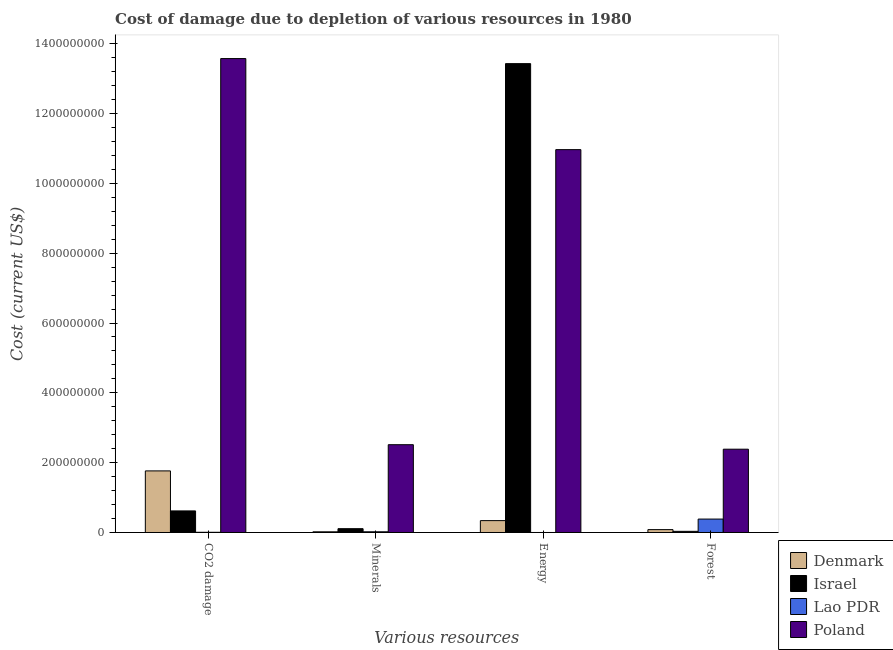How many different coloured bars are there?
Make the answer very short. 4. Are the number of bars on each tick of the X-axis equal?
Your response must be concise. Yes. How many bars are there on the 3rd tick from the left?
Your answer should be compact. 4. How many bars are there on the 2nd tick from the right?
Your answer should be very brief. 4. What is the label of the 3rd group of bars from the left?
Provide a short and direct response. Energy. What is the cost of damage due to depletion of minerals in Israel?
Offer a very short reply. 1.09e+07. Across all countries, what is the maximum cost of damage due to depletion of energy?
Make the answer very short. 1.34e+09. Across all countries, what is the minimum cost of damage due to depletion of minerals?
Your answer should be very brief. 1.95e+06. In which country was the cost of damage due to depletion of coal maximum?
Offer a very short reply. Poland. What is the total cost of damage due to depletion of forests in the graph?
Provide a short and direct response. 2.89e+08. What is the difference between the cost of damage due to depletion of coal in Israel and that in Lao PDR?
Keep it short and to the point. 6.12e+07. What is the difference between the cost of damage due to depletion of energy in Lao PDR and the cost of damage due to depletion of minerals in Poland?
Offer a terse response. -2.51e+08. What is the average cost of damage due to depletion of coal per country?
Ensure brevity in your answer.  3.99e+08. What is the difference between the cost of damage due to depletion of minerals and cost of damage due to depletion of forests in Lao PDR?
Offer a very short reply. -3.64e+07. What is the ratio of the cost of damage due to depletion of coal in Israel to that in Lao PDR?
Make the answer very short. 113.08. Is the cost of damage due to depletion of minerals in Israel less than that in Denmark?
Provide a short and direct response. No. What is the difference between the highest and the second highest cost of damage due to depletion of energy?
Keep it short and to the point. 2.46e+08. What is the difference between the highest and the lowest cost of damage due to depletion of energy?
Offer a very short reply. 1.34e+09. In how many countries, is the cost of damage due to depletion of forests greater than the average cost of damage due to depletion of forests taken over all countries?
Make the answer very short. 1. What does the 1st bar from the left in Forest represents?
Keep it short and to the point. Denmark. How many bars are there?
Give a very brief answer. 16. How many countries are there in the graph?
Provide a short and direct response. 4. How many legend labels are there?
Offer a very short reply. 4. What is the title of the graph?
Give a very brief answer. Cost of damage due to depletion of various resources in 1980 . What is the label or title of the X-axis?
Offer a very short reply. Various resources. What is the label or title of the Y-axis?
Ensure brevity in your answer.  Cost (current US$). What is the Cost (current US$) of Denmark in CO2 damage?
Ensure brevity in your answer.  1.76e+08. What is the Cost (current US$) of Israel in CO2 damage?
Ensure brevity in your answer.  6.18e+07. What is the Cost (current US$) in Lao PDR in CO2 damage?
Ensure brevity in your answer.  5.46e+05. What is the Cost (current US$) of Poland in CO2 damage?
Offer a very short reply. 1.36e+09. What is the Cost (current US$) of Denmark in Minerals?
Offer a terse response. 1.95e+06. What is the Cost (current US$) in Israel in Minerals?
Your response must be concise. 1.09e+07. What is the Cost (current US$) in Lao PDR in Minerals?
Give a very brief answer. 1.98e+06. What is the Cost (current US$) of Poland in Minerals?
Your answer should be compact. 2.51e+08. What is the Cost (current US$) of Denmark in Energy?
Your answer should be compact. 3.40e+07. What is the Cost (current US$) of Israel in Energy?
Provide a short and direct response. 1.34e+09. What is the Cost (current US$) of Lao PDR in Energy?
Your answer should be compact. 831.51. What is the Cost (current US$) of Poland in Energy?
Provide a succinct answer. 1.10e+09. What is the Cost (current US$) in Denmark in Forest?
Your response must be concise. 8.22e+06. What is the Cost (current US$) of Israel in Forest?
Your answer should be very brief. 3.30e+06. What is the Cost (current US$) of Lao PDR in Forest?
Keep it short and to the point. 3.84e+07. What is the Cost (current US$) of Poland in Forest?
Keep it short and to the point. 2.39e+08. Across all Various resources, what is the maximum Cost (current US$) of Denmark?
Your response must be concise. 1.76e+08. Across all Various resources, what is the maximum Cost (current US$) of Israel?
Offer a very short reply. 1.34e+09. Across all Various resources, what is the maximum Cost (current US$) in Lao PDR?
Provide a succinct answer. 3.84e+07. Across all Various resources, what is the maximum Cost (current US$) of Poland?
Offer a terse response. 1.36e+09. Across all Various resources, what is the minimum Cost (current US$) in Denmark?
Make the answer very short. 1.95e+06. Across all Various resources, what is the minimum Cost (current US$) of Israel?
Keep it short and to the point. 3.30e+06. Across all Various resources, what is the minimum Cost (current US$) in Lao PDR?
Your response must be concise. 831.51. Across all Various resources, what is the minimum Cost (current US$) of Poland?
Your answer should be compact. 2.39e+08. What is the total Cost (current US$) in Denmark in the graph?
Your answer should be compact. 2.21e+08. What is the total Cost (current US$) in Israel in the graph?
Offer a terse response. 1.42e+09. What is the total Cost (current US$) in Lao PDR in the graph?
Provide a short and direct response. 4.10e+07. What is the total Cost (current US$) in Poland in the graph?
Offer a very short reply. 2.94e+09. What is the difference between the Cost (current US$) in Denmark in CO2 damage and that in Minerals?
Keep it short and to the point. 1.74e+08. What is the difference between the Cost (current US$) in Israel in CO2 damage and that in Minerals?
Keep it short and to the point. 5.09e+07. What is the difference between the Cost (current US$) of Lao PDR in CO2 damage and that in Minerals?
Make the answer very short. -1.44e+06. What is the difference between the Cost (current US$) of Poland in CO2 damage and that in Minerals?
Your answer should be very brief. 1.11e+09. What is the difference between the Cost (current US$) in Denmark in CO2 damage and that in Energy?
Keep it short and to the point. 1.42e+08. What is the difference between the Cost (current US$) of Israel in CO2 damage and that in Energy?
Provide a short and direct response. -1.28e+09. What is the difference between the Cost (current US$) of Lao PDR in CO2 damage and that in Energy?
Give a very brief answer. 5.46e+05. What is the difference between the Cost (current US$) of Poland in CO2 damage and that in Energy?
Provide a succinct answer. 2.61e+08. What is the difference between the Cost (current US$) of Denmark in CO2 damage and that in Forest?
Provide a succinct answer. 1.68e+08. What is the difference between the Cost (current US$) in Israel in CO2 damage and that in Forest?
Your answer should be compact. 5.85e+07. What is the difference between the Cost (current US$) of Lao PDR in CO2 damage and that in Forest?
Your answer should be compact. -3.79e+07. What is the difference between the Cost (current US$) in Poland in CO2 damage and that in Forest?
Make the answer very short. 1.12e+09. What is the difference between the Cost (current US$) of Denmark in Minerals and that in Energy?
Offer a terse response. -3.20e+07. What is the difference between the Cost (current US$) of Israel in Minerals and that in Energy?
Offer a very short reply. -1.33e+09. What is the difference between the Cost (current US$) of Lao PDR in Minerals and that in Energy?
Provide a short and direct response. 1.98e+06. What is the difference between the Cost (current US$) in Poland in Minerals and that in Energy?
Your response must be concise. -8.45e+08. What is the difference between the Cost (current US$) of Denmark in Minerals and that in Forest?
Keep it short and to the point. -6.27e+06. What is the difference between the Cost (current US$) in Israel in Minerals and that in Forest?
Offer a terse response. 7.59e+06. What is the difference between the Cost (current US$) in Lao PDR in Minerals and that in Forest?
Provide a short and direct response. -3.64e+07. What is the difference between the Cost (current US$) of Poland in Minerals and that in Forest?
Ensure brevity in your answer.  1.29e+07. What is the difference between the Cost (current US$) of Denmark in Energy and that in Forest?
Offer a very short reply. 2.58e+07. What is the difference between the Cost (current US$) of Israel in Energy and that in Forest?
Provide a succinct answer. 1.34e+09. What is the difference between the Cost (current US$) of Lao PDR in Energy and that in Forest?
Your answer should be very brief. -3.84e+07. What is the difference between the Cost (current US$) of Poland in Energy and that in Forest?
Your response must be concise. 8.58e+08. What is the difference between the Cost (current US$) in Denmark in CO2 damage and the Cost (current US$) in Israel in Minerals?
Provide a succinct answer. 1.66e+08. What is the difference between the Cost (current US$) in Denmark in CO2 damage and the Cost (current US$) in Lao PDR in Minerals?
Make the answer very short. 1.74e+08. What is the difference between the Cost (current US$) of Denmark in CO2 damage and the Cost (current US$) of Poland in Minerals?
Your answer should be compact. -7.51e+07. What is the difference between the Cost (current US$) in Israel in CO2 damage and the Cost (current US$) in Lao PDR in Minerals?
Your response must be concise. 5.98e+07. What is the difference between the Cost (current US$) in Israel in CO2 damage and the Cost (current US$) in Poland in Minerals?
Offer a terse response. -1.90e+08. What is the difference between the Cost (current US$) in Lao PDR in CO2 damage and the Cost (current US$) in Poland in Minerals?
Ensure brevity in your answer.  -2.51e+08. What is the difference between the Cost (current US$) of Denmark in CO2 damage and the Cost (current US$) of Israel in Energy?
Offer a terse response. -1.17e+09. What is the difference between the Cost (current US$) of Denmark in CO2 damage and the Cost (current US$) of Lao PDR in Energy?
Offer a terse response. 1.76e+08. What is the difference between the Cost (current US$) of Denmark in CO2 damage and the Cost (current US$) of Poland in Energy?
Make the answer very short. -9.20e+08. What is the difference between the Cost (current US$) of Israel in CO2 damage and the Cost (current US$) of Lao PDR in Energy?
Offer a very short reply. 6.18e+07. What is the difference between the Cost (current US$) in Israel in CO2 damage and the Cost (current US$) in Poland in Energy?
Keep it short and to the point. -1.03e+09. What is the difference between the Cost (current US$) in Lao PDR in CO2 damage and the Cost (current US$) in Poland in Energy?
Your answer should be compact. -1.10e+09. What is the difference between the Cost (current US$) of Denmark in CO2 damage and the Cost (current US$) of Israel in Forest?
Offer a terse response. 1.73e+08. What is the difference between the Cost (current US$) in Denmark in CO2 damage and the Cost (current US$) in Lao PDR in Forest?
Offer a very short reply. 1.38e+08. What is the difference between the Cost (current US$) in Denmark in CO2 damage and the Cost (current US$) in Poland in Forest?
Provide a short and direct response. -6.22e+07. What is the difference between the Cost (current US$) of Israel in CO2 damage and the Cost (current US$) of Lao PDR in Forest?
Your response must be concise. 2.34e+07. What is the difference between the Cost (current US$) in Israel in CO2 damage and the Cost (current US$) in Poland in Forest?
Your response must be concise. -1.77e+08. What is the difference between the Cost (current US$) of Lao PDR in CO2 damage and the Cost (current US$) of Poland in Forest?
Ensure brevity in your answer.  -2.38e+08. What is the difference between the Cost (current US$) in Denmark in Minerals and the Cost (current US$) in Israel in Energy?
Provide a succinct answer. -1.34e+09. What is the difference between the Cost (current US$) of Denmark in Minerals and the Cost (current US$) of Lao PDR in Energy?
Offer a terse response. 1.95e+06. What is the difference between the Cost (current US$) of Denmark in Minerals and the Cost (current US$) of Poland in Energy?
Your answer should be compact. -1.09e+09. What is the difference between the Cost (current US$) in Israel in Minerals and the Cost (current US$) in Lao PDR in Energy?
Offer a terse response. 1.09e+07. What is the difference between the Cost (current US$) of Israel in Minerals and the Cost (current US$) of Poland in Energy?
Keep it short and to the point. -1.09e+09. What is the difference between the Cost (current US$) in Lao PDR in Minerals and the Cost (current US$) in Poland in Energy?
Offer a very short reply. -1.09e+09. What is the difference between the Cost (current US$) of Denmark in Minerals and the Cost (current US$) of Israel in Forest?
Provide a succinct answer. -1.34e+06. What is the difference between the Cost (current US$) of Denmark in Minerals and the Cost (current US$) of Lao PDR in Forest?
Make the answer very short. -3.65e+07. What is the difference between the Cost (current US$) in Denmark in Minerals and the Cost (current US$) in Poland in Forest?
Offer a very short reply. -2.37e+08. What is the difference between the Cost (current US$) of Israel in Minerals and the Cost (current US$) of Lao PDR in Forest?
Your answer should be compact. -2.75e+07. What is the difference between the Cost (current US$) in Israel in Minerals and the Cost (current US$) in Poland in Forest?
Your answer should be compact. -2.28e+08. What is the difference between the Cost (current US$) of Lao PDR in Minerals and the Cost (current US$) of Poland in Forest?
Ensure brevity in your answer.  -2.37e+08. What is the difference between the Cost (current US$) in Denmark in Energy and the Cost (current US$) in Israel in Forest?
Offer a very short reply. 3.07e+07. What is the difference between the Cost (current US$) of Denmark in Energy and the Cost (current US$) of Lao PDR in Forest?
Provide a succinct answer. -4.46e+06. What is the difference between the Cost (current US$) of Denmark in Energy and the Cost (current US$) of Poland in Forest?
Make the answer very short. -2.05e+08. What is the difference between the Cost (current US$) in Israel in Energy and the Cost (current US$) in Lao PDR in Forest?
Make the answer very short. 1.30e+09. What is the difference between the Cost (current US$) of Israel in Energy and the Cost (current US$) of Poland in Forest?
Offer a very short reply. 1.10e+09. What is the difference between the Cost (current US$) in Lao PDR in Energy and the Cost (current US$) in Poland in Forest?
Provide a short and direct response. -2.39e+08. What is the average Cost (current US$) in Denmark per Various resources?
Your response must be concise. 5.51e+07. What is the average Cost (current US$) of Israel per Various resources?
Provide a short and direct response. 3.55e+08. What is the average Cost (current US$) in Lao PDR per Various resources?
Provide a succinct answer. 1.02e+07. What is the average Cost (current US$) in Poland per Various resources?
Keep it short and to the point. 7.36e+08. What is the difference between the Cost (current US$) of Denmark and Cost (current US$) of Israel in CO2 damage?
Ensure brevity in your answer.  1.15e+08. What is the difference between the Cost (current US$) of Denmark and Cost (current US$) of Lao PDR in CO2 damage?
Make the answer very short. 1.76e+08. What is the difference between the Cost (current US$) of Denmark and Cost (current US$) of Poland in CO2 damage?
Your answer should be very brief. -1.18e+09. What is the difference between the Cost (current US$) in Israel and Cost (current US$) in Lao PDR in CO2 damage?
Offer a very short reply. 6.12e+07. What is the difference between the Cost (current US$) of Israel and Cost (current US$) of Poland in CO2 damage?
Your answer should be compact. -1.30e+09. What is the difference between the Cost (current US$) in Lao PDR and Cost (current US$) in Poland in CO2 damage?
Ensure brevity in your answer.  -1.36e+09. What is the difference between the Cost (current US$) of Denmark and Cost (current US$) of Israel in Minerals?
Offer a terse response. -8.93e+06. What is the difference between the Cost (current US$) in Denmark and Cost (current US$) in Lao PDR in Minerals?
Your response must be concise. -3.09e+04. What is the difference between the Cost (current US$) in Denmark and Cost (current US$) in Poland in Minerals?
Offer a very short reply. -2.50e+08. What is the difference between the Cost (current US$) in Israel and Cost (current US$) in Lao PDR in Minerals?
Keep it short and to the point. 8.90e+06. What is the difference between the Cost (current US$) in Israel and Cost (current US$) in Poland in Minerals?
Provide a short and direct response. -2.41e+08. What is the difference between the Cost (current US$) of Lao PDR and Cost (current US$) of Poland in Minerals?
Your answer should be very brief. -2.49e+08. What is the difference between the Cost (current US$) in Denmark and Cost (current US$) in Israel in Energy?
Keep it short and to the point. -1.31e+09. What is the difference between the Cost (current US$) in Denmark and Cost (current US$) in Lao PDR in Energy?
Provide a short and direct response. 3.40e+07. What is the difference between the Cost (current US$) in Denmark and Cost (current US$) in Poland in Energy?
Give a very brief answer. -1.06e+09. What is the difference between the Cost (current US$) in Israel and Cost (current US$) in Lao PDR in Energy?
Your response must be concise. 1.34e+09. What is the difference between the Cost (current US$) in Israel and Cost (current US$) in Poland in Energy?
Offer a terse response. 2.46e+08. What is the difference between the Cost (current US$) in Lao PDR and Cost (current US$) in Poland in Energy?
Provide a succinct answer. -1.10e+09. What is the difference between the Cost (current US$) of Denmark and Cost (current US$) of Israel in Forest?
Provide a short and direct response. 4.93e+06. What is the difference between the Cost (current US$) in Denmark and Cost (current US$) in Lao PDR in Forest?
Provide a short and direct response. -3.02e+07. What is the difference between the Cost (current US$) of Denmark and Cost (current US$) of Poland in Forest?
Give a very brief answer. -2.30e+08. What is the difference between the Cost (current US$) of Israel and Cost (current US$) of Lao PDR in Forest?
Your answer should be compact. -3.51e+07. What is the difference between the Cost (current US$) in Israel and Cost (current US$) in Poland in Forest?
Your answer should be very brief. -2.35e+08. What is the difference between the Cost (current US$) of Lao PDR and Cost (current US$) of Poland in Forest?
Ensure brevity in your answer.  -2.00e+08. What is the ratio of the Cost (current US$) of Denmark in CO2 damage to that in Minerals?
Provide a short and direct response. 90.3. What is the ratio of the Cost (current US$) of Israel in CO2 damage to that in Minerals?
Offer a terse response. 5.68. What is the ratio of the Cost (current US$) of Lao PDR in CO2 damage to that in Minerals?
Make the answer very short. 0.28. What is the ratio of the Cost (current US$) of Poland in CO2 damage to that in Minerals?
Your answer should be compact. 5.4. What is the ratio of the Cost (current US$) in Denmark in CO2 damage to that in Energy?
Give a very brief answer. 5.19. What is the ratio of the Cost (current US$) in Israel in CO2 damage to that in Energy?
Make the answer very short. 0.05. What is the ratio of the Cost (current US$) in Lao PDR in CO2 damage to that in Energy?
Make the answer very short. 657.18. What is the ratio of the Cost (current US$) in Poland in CO2 damage to that in Energy?
Provide a short and direct response. 1.24. What is the ratio of the Cost (current US$) in Denmark in CO2 damage to that in Forest?
Provide a short and direct response. 21.45. What is the ratio of the Cost (current US$) of Israel in CO2 damage to that in Forest?
Your response must be concise. 18.74. What is the ratio of the Cost (current US$) in Lao PDR in CO2 damage to that in Forest?
Provide a short and direct response. 0.01. What is the ratio of the Cost (current US$) in Poland in CO2 damage to that in Forest?
Your answer should be compact. 5.69. What is the ratio of the Cost (current US$) of Denmark in Minerals to that in Energy?
Offer a terse response. 0.06. What is the ratio of the Cost (current US$) of Israel in Minerals to that in Energy?
Provide a succinct answer. 0.01. What is the ratio of the Cost (current US$) of Lao PDR in Minerals to that in Energy?
Make the answer very short. 2386.4. What is the ratio of the Cost (current US$) of Poland in Minerals to that in Energy?
Keep it short and to the point. 0.23. What is the ratio of the Cost (current US$) of Denmark in Minerals to that in Forest?
Your answer should be compact. 0.24. What is the ratio of the Cost (current US$) of Israel in Minerals to that in Forest?
Your answer should be very brief. 3.3. What is the ratio of the Cost (current US$) of Lao PDR in Minerals to that in Forest?
Give a very brief answer. 0.05. What is the ratio of the Cost (current US$) of Poland in Minerals to that in Forest?
Your response must be concise. 1.05. What is the ratio of the Cost (current US$) in Denmark in Energy to that in Forest?
Offer a very short reply. 4.13. What is the ratio of the Cost (current US$) in Israel in Energy to that in Forest?
Your answer should be very brief. 407.28. What is the ratio of the Cost (current US$) in Lao PDR in Energy to that in Forest?
Ensure brevity in your answer.  0. What is the ratio of the Cost (current US$) of Poland in Energy to that in Forest?
Ensure brevity in your answer.  4.6. What is the difference between the highest and the second highest Cost (current US$) of Denmark?
Offer a terse response. 1.42e+08. What is the difference between the highest and the second highest Cost (current US$) of Israel?
Offer a terse response. 1.28e+09. What is the difference between the highest and the second highest Cost (current US$) in Lao PDR?
Your response must be concise. 3.64e+07. What is the difference between the highest and the second highest Cost (current US$) of Poland?
Give a very brief answer. 2.61e+08. What is the difference between the highest and the lowest Cost (current US$) in Denmark?
Make the answer very short. 1.74e+08. What is the difference between the highest and the lowest Cost (current US$) in Israel?
Provide a succinct answer. 1.34e+09. What is the difference between the highest and the lowest Cost (current US$) in Lao PDR?
Offer a terse response. 3.84e+07. What is the difference between the highest and the lowest Cost (current US$) of Poland?
Your response must be concise. 1.12e+09. 